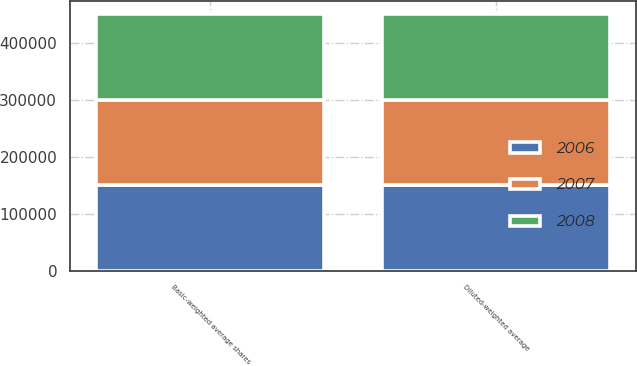Convert chart to OTSL. <chart><loc_0><loc_0><loc_500><loc_500><stacked_bar_chart><ecel><fcel>Basic-weighted average shares<fcel>Diluted-weighted average<nl><fcel>2007<fcel>148831<fcel>148831<nl><fcel>2008<fcel>150555<fcel>150555<nl><fcel>2006<fcel>151034<fcel>151165<nl></chart> 